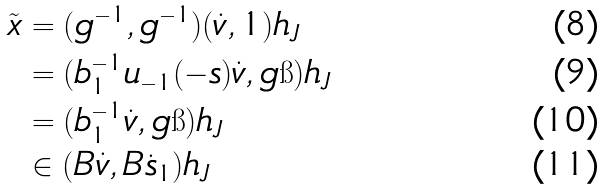<formula> <loc_0><loc_0><loc_500><loc_500>\tilde { x } & = ( g ^ { - 1 } , g ^ { - 1 } ) ( \dot { v } , 1 ) { h } _ { J } \\ & = ( b _ { 1 } ^ { - 1 } u _ { - 1 } ( - s ) \dot { v } , g \i ) { h } _ { J } \\ & = ( b _ { 1 } ^ { - 1 } \dot { v } , g \i ) { h } _ { J } \\ & \in ( B \dot { v } , B \dot { s } _ { 1 } ) { h } _ { J }</formula> 